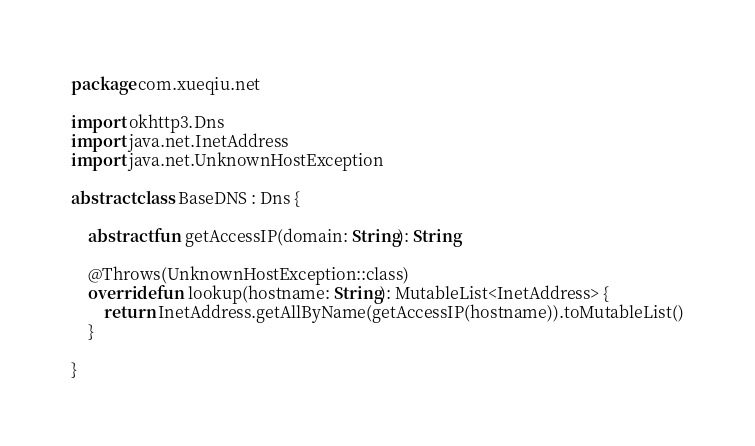Convert code to text. <code><loc_0><loc_0><loc_500><loc_500><_Kotlin_>package com.xueqiu.net

import okhttp3.Dns
import java.net.InetAddress
import java.net.UnknownHostException

abstract class BaseDNS : Dns {

    abstract fun getAccessIP(domain: String): String

    @Throws(UnknownHostException::class)
    override fun lookup(hostname: String): MutableList<InetAddress> {
        return InetAddress.getAllByName(getAccessIP(hostname)).toMutableList()
    }

}</code> 